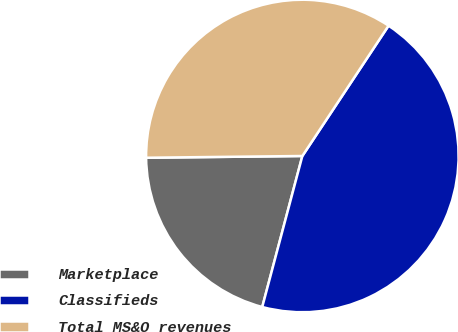<chart> <loc_0><loc_0><loc_500><loc_500><pie_chart><fcel>Marketplace<fcel>Classifieds<fcel>Total MS&O revenues<nl><fcel>20.69%<fcel>44.83%<fcel>34.48%<nl></chart> 